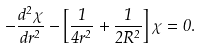<formula> <loc_0><loc_0><loc_500><loc_500>- \frac { d ^ { 2 } \chi } { d r ^ { 2 } } - \left [ \frac { 1 } { 4 r ^ { 2 } } + \frac { 1 } { 2 R ^ { 2 } } \right ] \chi = 0 .</formula> 